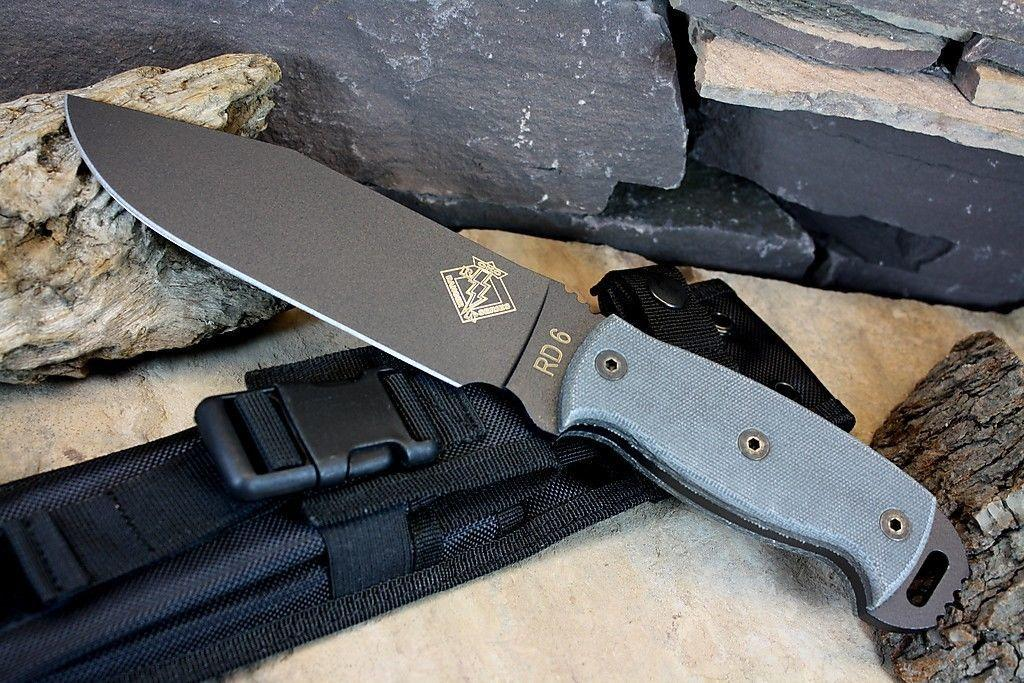What object is placed on the pouch in the image? There is a knife placed on a pouch in the image. What can be seen in the background of the image? Rocks are visible in the background of the image. What type of ghost can be seen haunting the roof in the image? There is no ghost or roof present in the image; it only features a knife placed on a pouch and rocks in the background. 